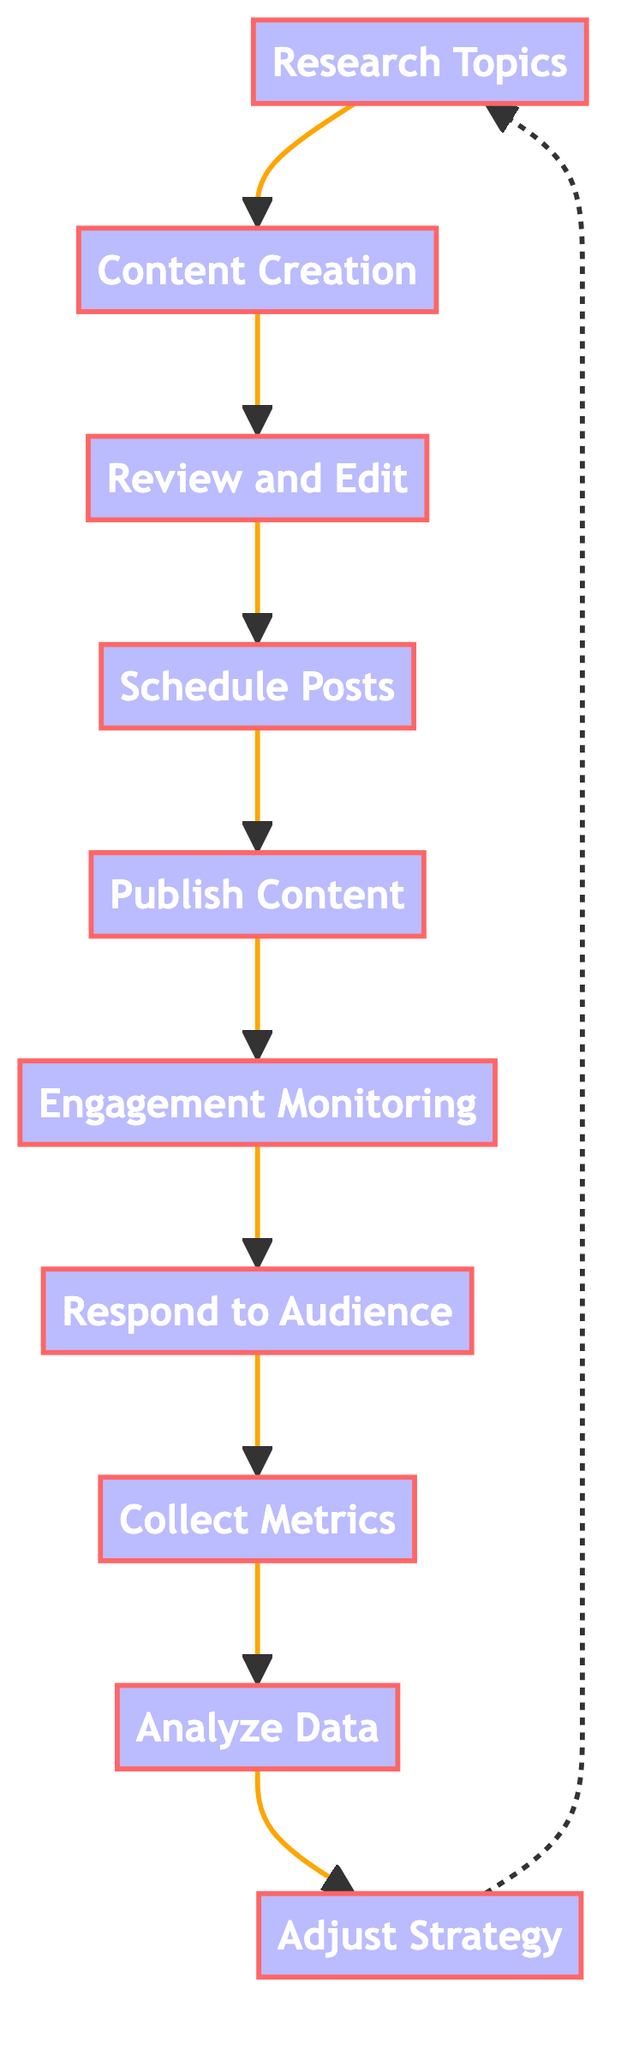What is the first action to raise awareness on social media? The diagram starts with the "Research Topics" node, which is the first action in the sequence.
Answer: Research Topics How many total steps are depicted in this flow chart? The diagram contains ten distinct processes from start to end.
Answer: 10 What follows after "Content Creation"? After "Content Creation," the next step in the flow is "Review and Edit," indicating a need to ensure information quality.
Answer: Review and Edit Which action comes directly after "Collect Metrics"? The action that follows "Collect Metrics" is "Analyze Data," suggesting an evaluation of the metrics gathered.
Answer: Analyze Data How does the flow go from "Adjust Strategy"? The flow from "Adjust Strategy" leads back to "Research Topics," indicating that insights may loop back to re-evaluate issues.
Answer: Research Topics What type of content can be produced in "Content Creation"? The "Content Creation" node describes producing articles, visuals, and videos as forms of engaging content.
Answer: Articles, visuals, videos Which process involves gathering data on audience interactions? The "Collect Metrics" step is focused on gathering data regarding audience engagement such as reach, likes, and shares.
Answer: Collect Metrics Is there a step indicating interaction with the audience? Yes, the "Respond to Audience" step is explicitly about engaging with followers by replying to comments and messages.
Answer: Respond to Audience What is the role of "Engagement Monitoring"? The "Engagement Monitoring" node tracks audience reactions and interactions to gauge the effectiveness of the content.
Answer: Track audience reactions What does the "Analyze Data" step focus on? The "Analyze Data" step reviews the collected metrics to assess the impact of the social media efforts.
Answer: Assessing impact 